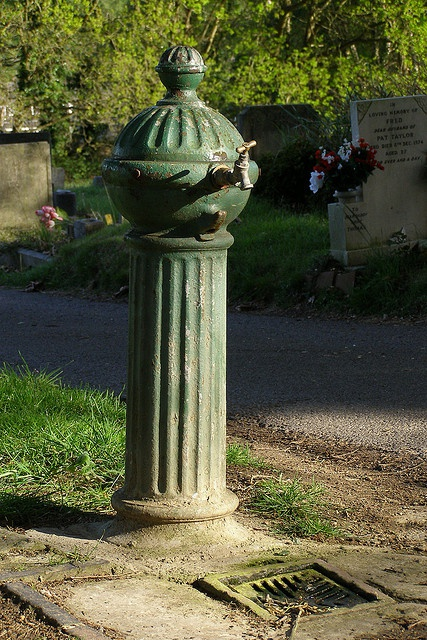Describe the objects in this image and their specific colors. I can see fire hydrant in darkgreen, black, beige, darkgray, and olive tones and potted plant in darkgreen, black, gray, and maroon tones in this image. 